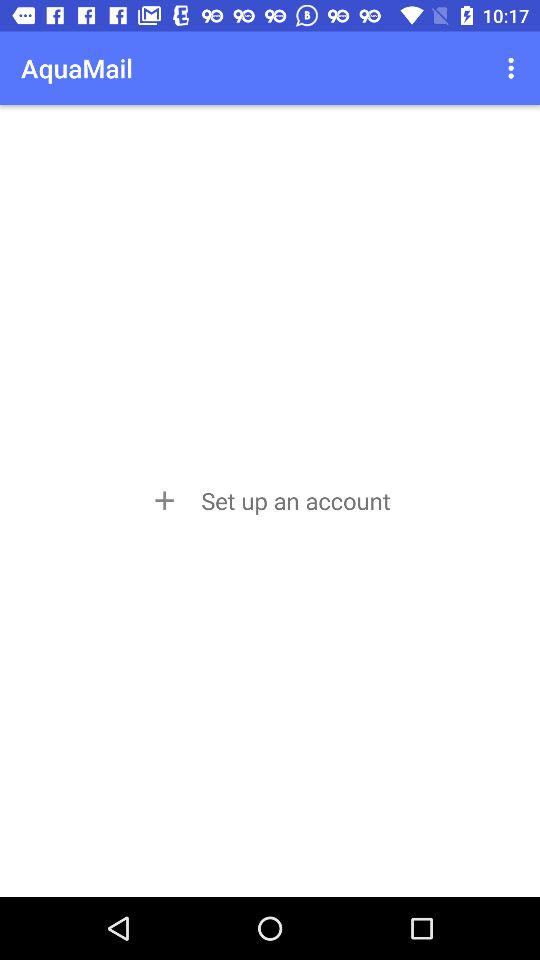What is the name of the application? The application name is "AquaMail". 